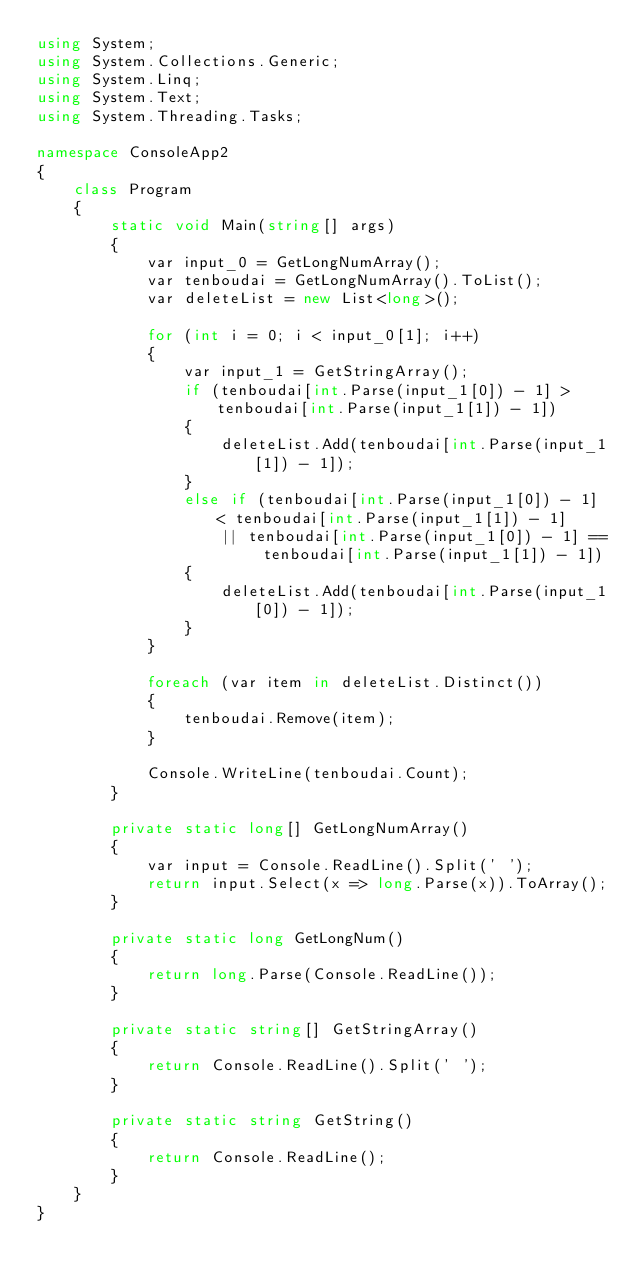Convert code to text. <code><loc_0><loc_0><loc_500><loc_500><_C#_>using System;
using System.Collections.Generic;
using System.Linq;
using System.Text;
using System.Threading.Tasks;

namespace ConsoleApp2
{
    class Program
    {
        static void Main(string[] args)
        {
            var input_0 = GetLongNumArray();
            var tenboudai = GetLongNumArray().ToList();
            var deleteList = new List<long>();

            for (int i = 0; i < input_0[1]; i++)
            {
                var input_1 = GetStringArray();
                if (tenboudai[int.Parse(input_1[0]) - 1] > tenboudai[int.Parse(input_1[1]) - 1])
                {
                    deleteList.Add(tenboudai[int.Parse(input_1[1]) - 1]);
                }
                else if (tenboudai[int.Parse(input_1[0]) - 1] < tenboudai[int.Parse(input_1[1]) - 1]
                    || tenboudai[int.Parse(input_1[0]) - 1] == tenboudai[int.Parse(input_1[1]) - 1])
                {
                    deleteList.Add(tenboudai[int.Parse(input_1[0]) - 1]);
                }
            }

            foreach (var item in deleteList.Distinct())
            {
                tenboudai.Remove(item);
            }

            Console.WriteLine(tenboudai.Count);
        }

        private static long[] GetLongNumArray()
        {
            var input = Console.ReadLine().Split(' ');
            return input.Select(x => long.Parse(x)).ToArray();
        }

        private static long GetLongNum()
        {
            return long.Parse(Console.ReadLine());
        }

        private static string[] GetStringArray()
        {
            return Console.ReadLine().Split(' ');
        }

        private static string GetString()
        {
            return Console.ReadLine();
        }
    }
}
</code> 